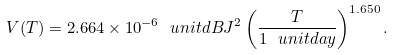<formula> <loc_0><loc_0><loc_500><loc_500>V ( T ) = 2 . 6 6 4 \times 1 0 ^ { - 6 } \ u n i t { d B J ^ { 2 } } \left ( \frac { T } { 1 \ u n i t { d a y } } \right ) ^ { 1 . 6 5 0 } .</formula> 